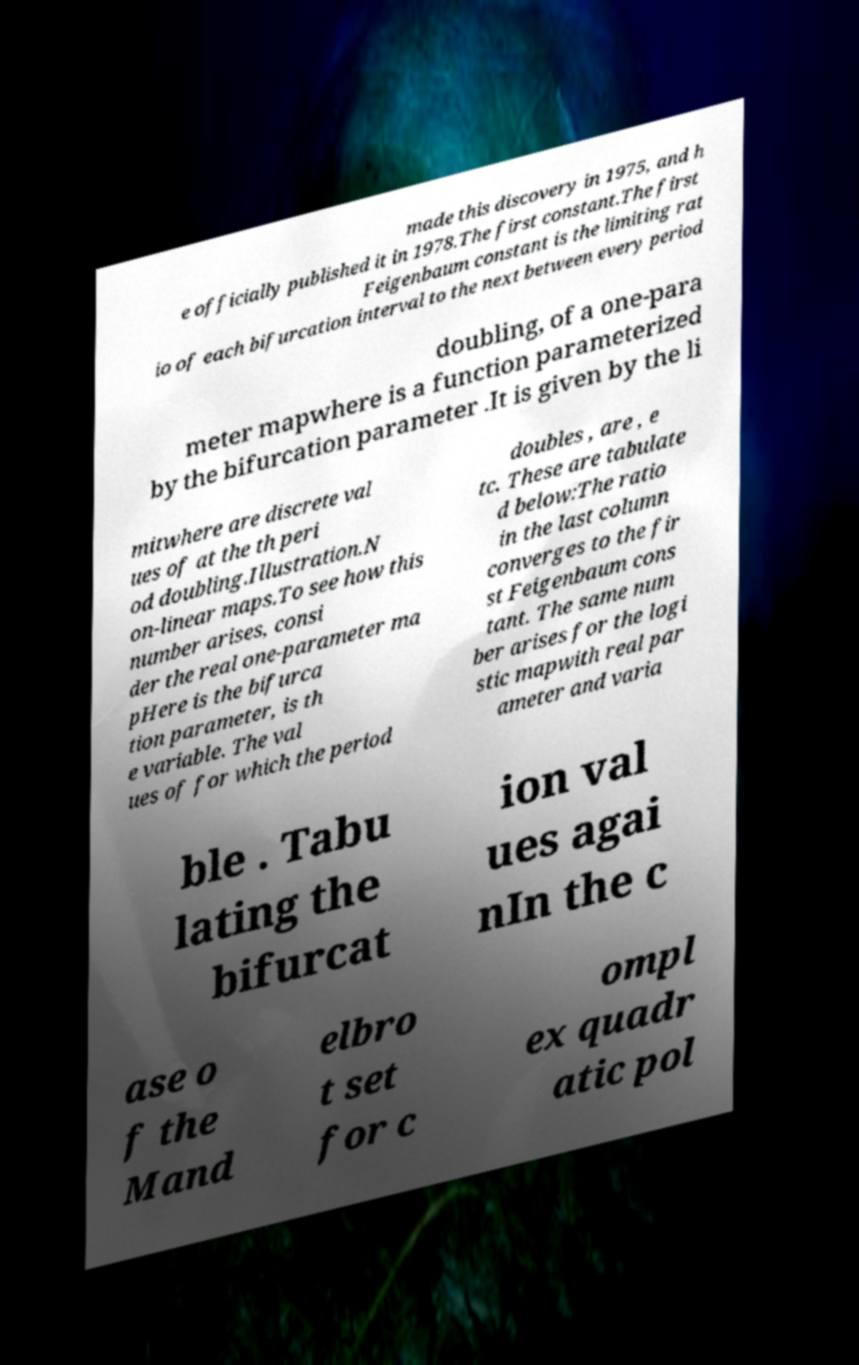Please read and relay the text visible in this image. What does it say? made this discovery in 1975, and h e officially published it in 1978.The first constant.The first Feigenbaum constant is the limiting rat io of each bifurcation interval to the next between every period doubling, of a one-para meter mapwhere is a function parameterized by the bifurcation parameter .It is given by the li mitwhere are discrete val ues of at the th peri od doubling.Illustration.N on-linear maps.To see how this number arises, consi der the real one-parameter ma pHere is the bifurca tion parameter, is th e variable. The val ues of for which the period doubles , are , e tc. These are tabulate d below:The ratio in the last column converges to the fir st Feigenbaum cons tant. The same num ber arises for the logi stic mapwith real par ameter and varia ble . Tabu lating the bifurcat ion val ues agai nIn the c ase o f the Mand elbro t set for c ompl ex quadr atic pol 